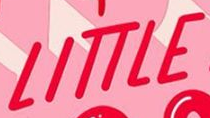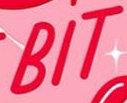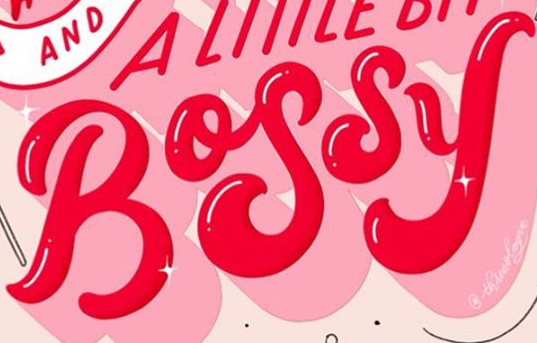Identify the words shown in these images in order, separated by a semicolon. LITTLE; BIT; BOSSY 